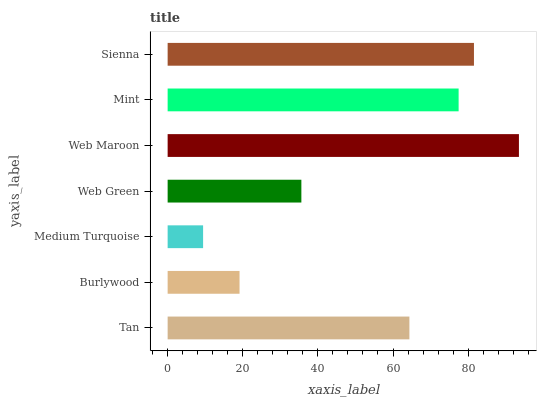Is Medium Turquoise the minimum?
Answer yes or no. Yes. Is Web Maroon the maximum?
Answer yes or no. Yes. Is Burlywood the minimum?
Answer yes or no. No. Is Burlywood the maximum?
Answer yes or no. No. Is Tan greater than Burlywood?
Answer yes or no. Yes. Is Burlywood less than Tan?
Answer yes or no. Yes. Is Burlywood greater than Tan?
Answer yes or no. No. Is Tan less than Burlywood?
Answer yes or no. No. Is Tan the high median?
Answer yes or no. Yes. Is Tan the low median?
Answer yes or no. Yes. Is Mint the high median?
Answer yes or no. No. Is Mint the low median?
Answer yes or no. No. 